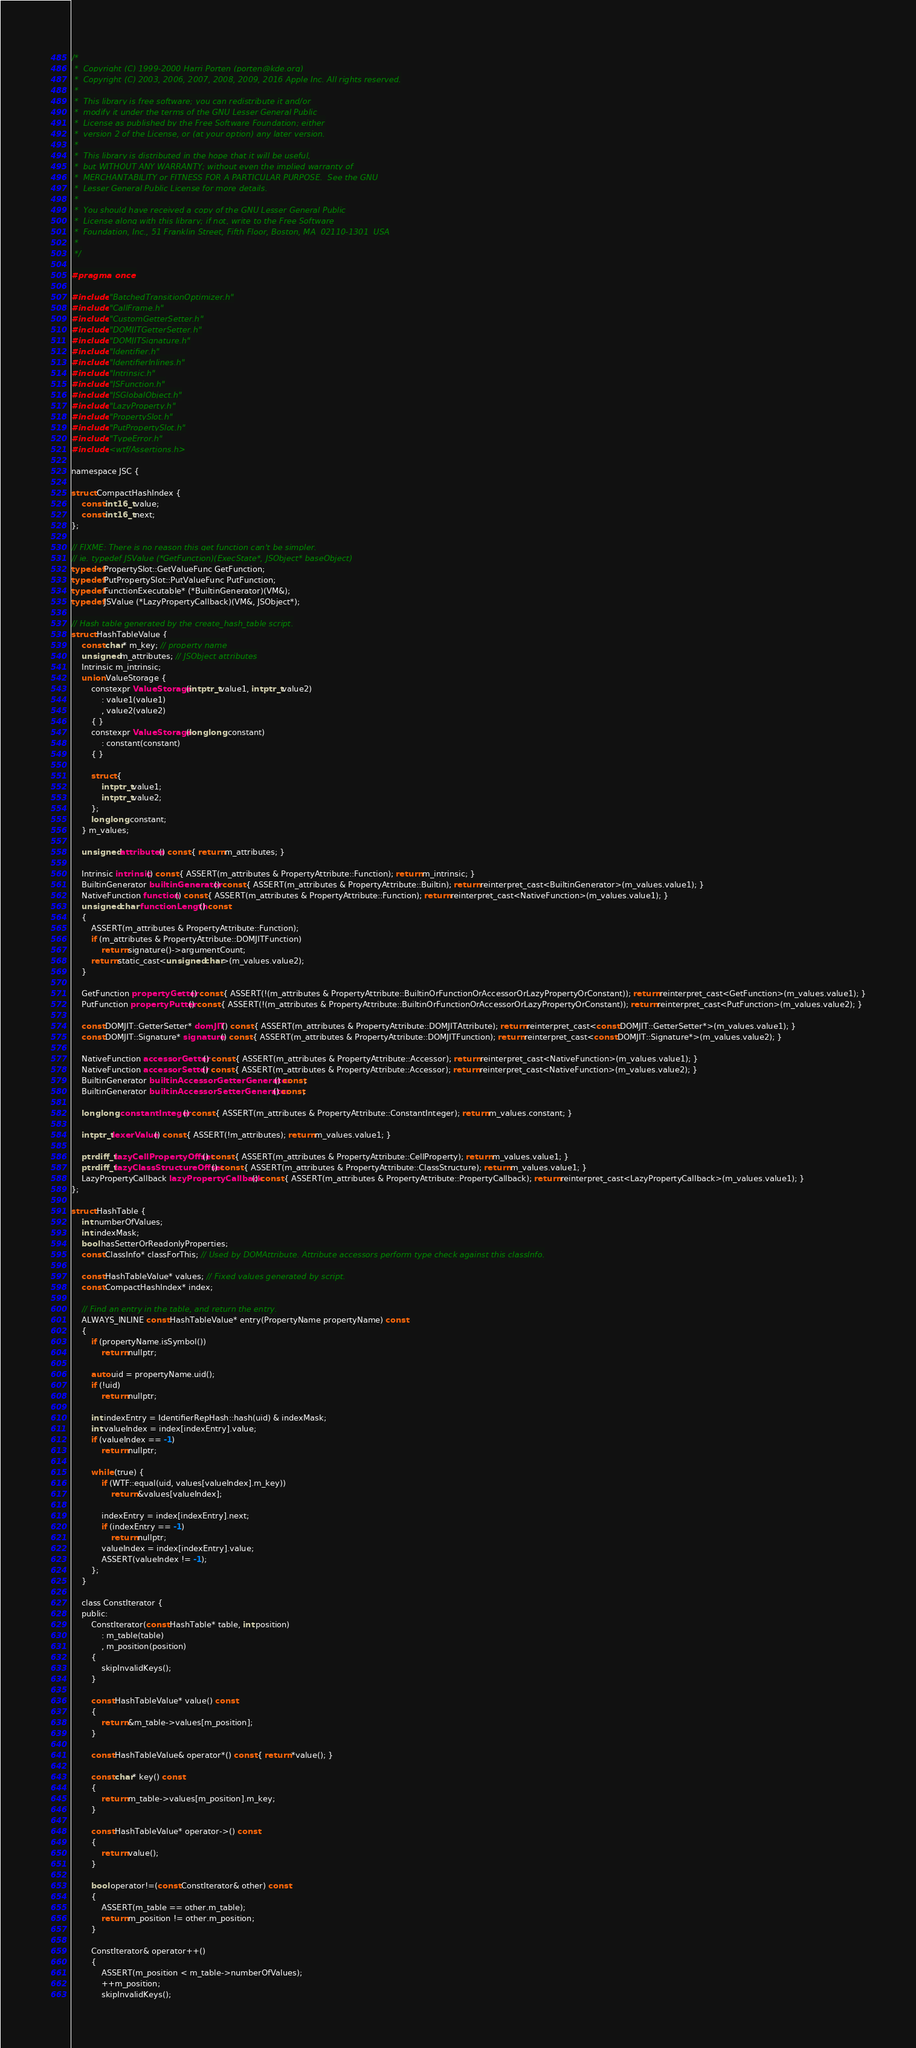<code> <loc_0><loc_0><loc_500><loc_500><_C_>/*
 *  Copyright (C) 1999-2000 Harri Porten (porten@kde.org)
 *  Copyright (C) 2003, 2006, 2007, 2008, 2009, 2016 Apple Inc. All rights reserved.
 *
 *  This library is free software; you can redistribute it and/or
 *  modify it under the terms of the GNU Lesser General Public
 *  License as published by the Free Software Foundation; either
 *  version 2 of the License, or (at your option) any later version.
 *
 *  This library is distributed in the hope that it will be useful,
 *  but WITHOUT ANY WARRANTY; without even the implied warranty of
 *  MERCHANTABILITY or FITNESS FOR A PARTICULAR PURPOSE.  See the GNU
 *  Lesser General Public License for more details.
 *
 *  You should have received a copy of the GNU Lesser General Public
 *  License along with this library; if not, write to the Free Software
 *  Foundation, Inc., 51 Franklin Street, Fifth Floor, Boston, MA  02110-1301  USA
 *
 */

#pragma once

#include "BatchedTransitionOptimizer.h"
#include "CallFrame.h"
#include "CustomGetterSetter.h"
#include "DOMJITGetterSetter.h"
#include "DOMJITSignature.h"
#include "Identifier.h"
#include "IdentifierInlines.h"
#include "Intrinsic.h"
#include "JSFunction.h"
#include "JSGlobalObject.h"
#include "LazyProperty.h"
#include "PropertySlot.h"
#include "PutPropertySlot.h"
#include "TypeError.h"
#include <wtf/Assertions.h>

namespace JSC {

struct CompactHashIndex {
    const int16_t value;
    const int16_t next;
};

// FIXME: There is no reason this get function can't be simpler.
// ie. typedef JSValue (*GetFunction)(ExecState*, JSObject* baseObject)
typedef PropertySlot::GetValueFunc GetFunction;
typedef PutPropertySlot::PutValueFunc PutFunction;
typedef FunctionExecutable* (*BuiltinGenerator)(VM&);
typedef JSValue (*LazyPropertyCallback)(VM&, JSObject*);

// Hash table generated by the create_hash_table script.
struct HashTableValue {
    const char* m_key; // property name
    unsigned m_attributes; // JSObject attributes
    Intrinsic m_intrinsic;
    union ValueStorage {
        constexpr ValueStorage(intptr_t value1, intptr_t value2)
            : value1(value1)
            , value2(value2)
        { }
        constexpr ValueStorage(long long constant)
            : constant(constant)
        { }

        struct {
            intptr_t value1;
            intptr_t value2;
        };
        long long constant;
    } m_values;

    unsigned attributes() const { return m_attributes; }

    Intrinsic intrinsic() const { ASSERT(m_attributes & PropertyAttribute::Function); return m_intrinsic; }
    BuiltinGenerator builtinGenerator() const { ASSERT(m_attributes & PropertyAttribute::Builtin); return reinterpret_cast<BuiltinGenerator>(m_values.value1); }
    NativeFunction function() const { ASSERT(m_attributes & PropertyAttribute::Function); return reinterpret_cast<NativeFunction>(m_values.value1); }
    unsigned char functionLength() const
    {
        ASSERT(m_attributes & PropertyAttribute::Function);
        if (m_attributes & PropertyAttribute::DOMJITFunction)
            return signature()->argumentCount;
        return static_cast<unsigned char>(m_values.value2);
    }

    GetFunction propertyGetter() const { ASSERT(!(m_attributes & PropertyAttribute::BuiltinOrFunctionOrAccessorOrLazyPropertyOrConstant)); return reinterpret_cast<GetFunction>(m_values.value1); }
    PutFunction propertyPutter() const { ASSERT(!(m_attributes & PropertyAttribute::BuiltinOrFunctionOrAccessorOrLazyPropertyOrConstant)); return reinterpret_cast<PutFunction>(m_values.value2); }

    const DOMJIT::GetterSetter* domJIT() const { ASSERT(m_attributes & PropertyAttribute::DOMJITAttribute); return reinterpret_cast<const DOMJIT::GetterSetter*>(m_values.value1); }
    const DOMJIT::Signature* signature() const { ASSERT(m_attributes & PropertyAttribute::DOMJITFunction); return reinterpret_cast<const DOMJIT::Signature*>(m_values.value2); }

    NativeFunction accessorGetter() const { ASSERT(m_attributes & PropertyAttribute::Accessor); return reinterpret_cast<NativeFunction>(m_values.value1); }
    NativeFunction accessorSetter() const { ASSERT(m_attributes & PropertyAttribute::Accessor); return reinterpret_cast<NativeFunction>(m_values.value2); }
    BuiltinGenerator builtinAccessorGetterGenerator() const;
    BuiltinGenerator builtinAccessorSetterGenerator() const;

    long long constantInteger() const { ASSERT(m_attributes & PropertyAttribute::ConstantInteger); return m_values.constant; }

    intptr_t lexerValue() const { ASSERT(!m_attributes); return m_values.value1; }
    
    ptrdiff_t lazyCellPropertyOffset() const { ASSERT(m_attributes & PropertyAttribute::CellProperty); return m_values.value1; }
    ptrdiff_t lazyClassStructureOffset() const { ASSERT(m_attributes & PropertyAttribute::ClassStructure); return m_values.value1; }
    LazyPropertyCallback lazyPropertyCallback() const { ASSERT(m_attributes & PropertyAttribute::PropertyCallback); return reinterpret_cast<LazyPropertyCallback>(m_values.value1); }
};

struct HashTable {
    int numberOfValues;
    int indexMask;
    bool hasSetterOrReadonlyProperties;
    const ClassInfo* classForThis; // Used by DOMAttribute. Attribute accessors perform type check against this classInfo.

    const HashTableValue* values; // Fixed values generated by script.
    const CompactHashIndex* index;

    // Find an entry in the table, and return the entry.
    ALWAYS_INLINE const HashTableValue* entry(PropertyName propertyName) const
    {
        if (propertyName.isSymbol())
            return nullptr;

        auto uid = propertyName.uid();
        if (!uid)
            return nullptr;

        int indexEntry = IdentifierRepHash::hash(uid) & indexMask;
        int valueIndex = index[indexEntry].value;
        if (valueIndex == -1)
            return nullptr;

        while (true) {
            if (WTF::equal(uid, values[valueIndex].m_key))
                return &values[valueIndex];

            indexEntry = index[indexEntry].next;
            if (indexEntry == -1)
                return nullptr;
            valueIndex = index[indexEntry].value;
            ASSERT(valueIndex != -1);
        };
    }

    class ConstIterator {
    public:
        ConstIterator(const HashTable* table, int position)
            : m_table(table)
            , m_position(position)
        {
            skipInvalidKeys();
        }

        const HashTableValue* value() const
        {
            return &m_table->values[m_position];
        }

        const HashTableValue& operator*() const { return *value(); }

        const char* key() const
        {
            return m_table->values[m_position].m_key;
        }

        const HashTableValue* operator->() const
        {
            return value();
        }

        bool operator!=(const ConstIterator& other) const
        {
            ASSERT(m_table == other.m_table);
            return m_position != other.m_position;
        }

        ConstIterator& operator++()
        {
            ASSERT(m_position < m_table->numberOfValues);
            ++m_position;
            skipInvalidKeys();</code> 